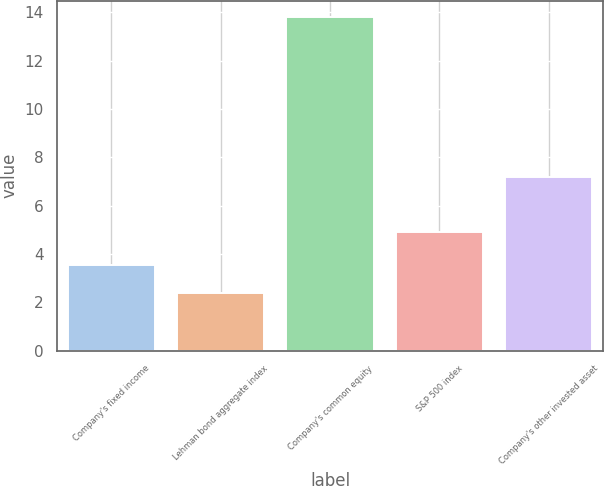Convert chart to OTSL. <chart><loc_0><loc_0><loc_500><loc_500><bar_chart><fcel>Company's fixed income<fcel>Lehman bond aggregate index<fcel>Company's common equity<fcel>S&P 500 index<fcel>Company's other invested asset<nl><fcel>3.54<fcel>2.4<fcel>13.8<fcel>4.9<fcel>7.2<nl></chart> 